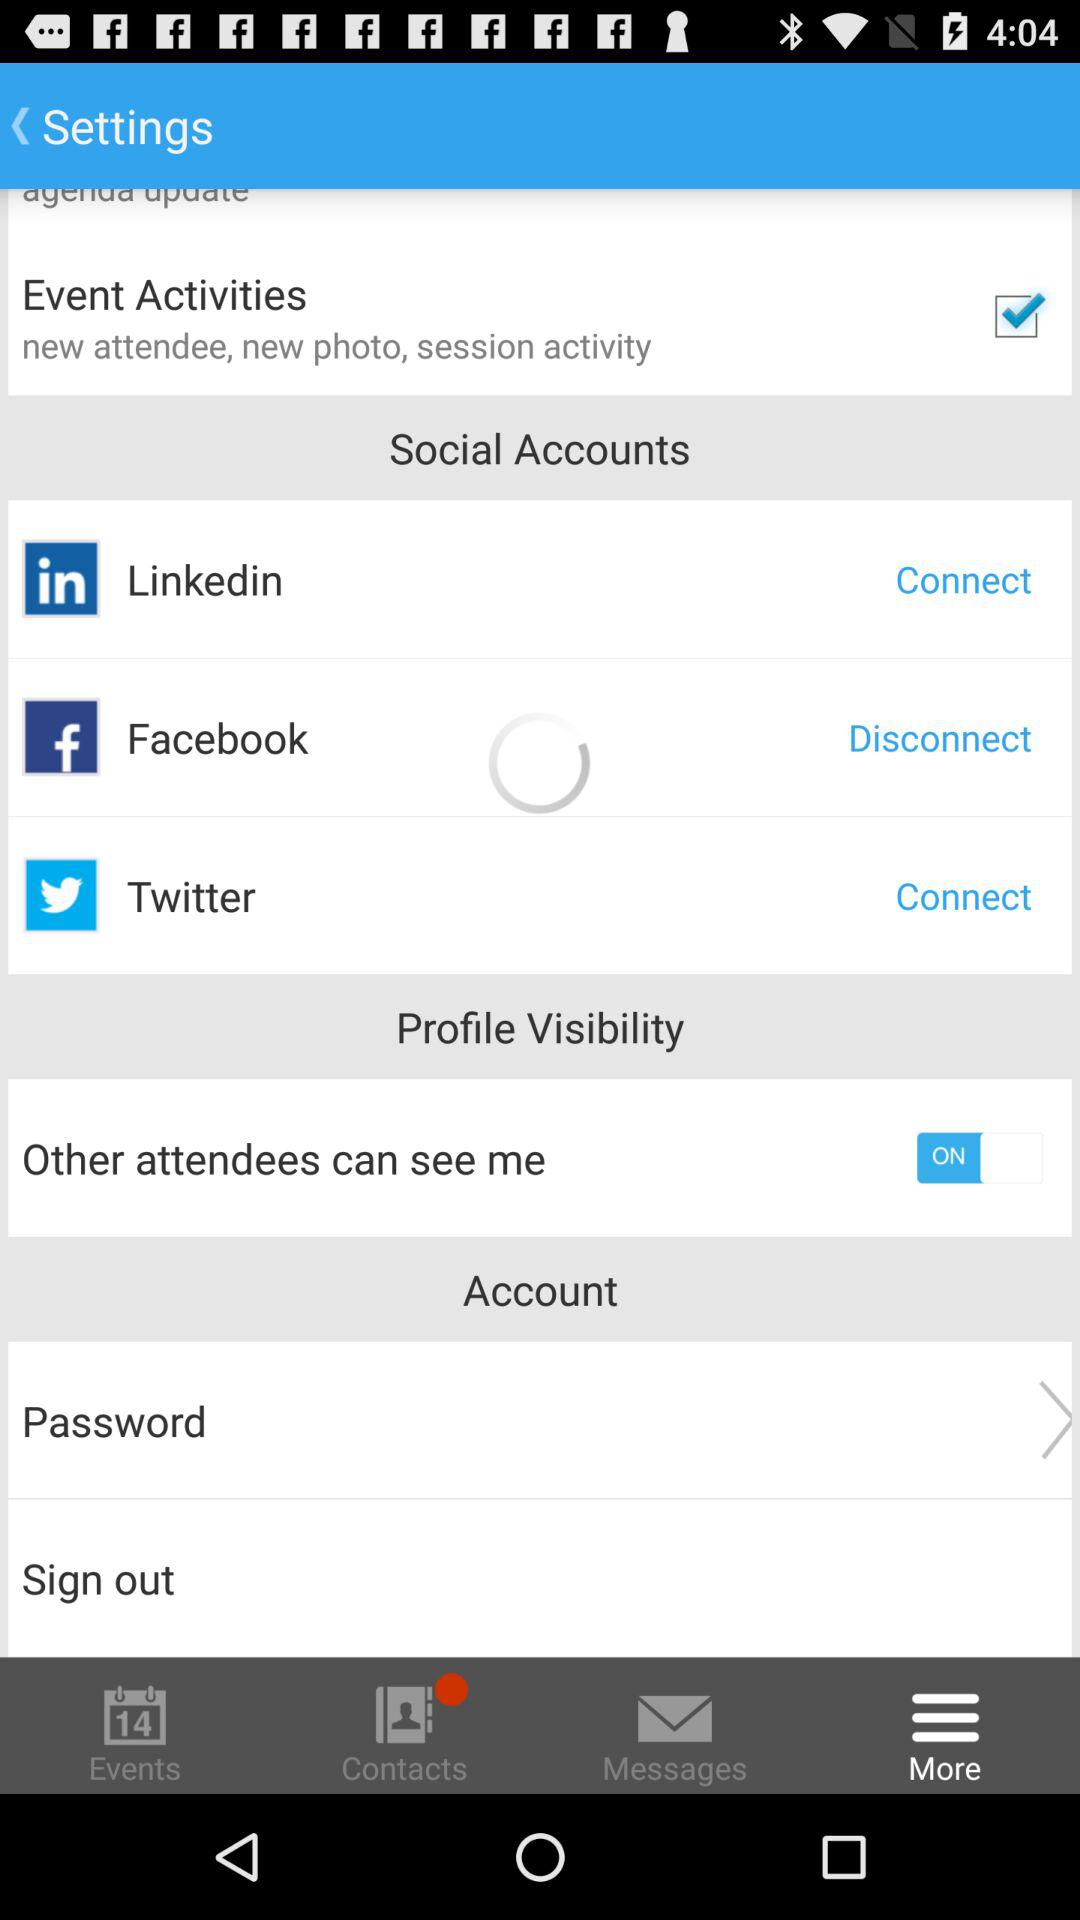Which social account can be disconnected? The social account that can be disconnected is "Facebook". 